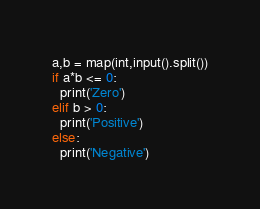<code> <loc_0><loc_0><loc_500><loc_500><_Python_>a,b = map(int,input().split())
if a*b <= 0:
  print('Zero')
elif b > 0:
  print('Positive')
else:
  print('Negative')</code> 